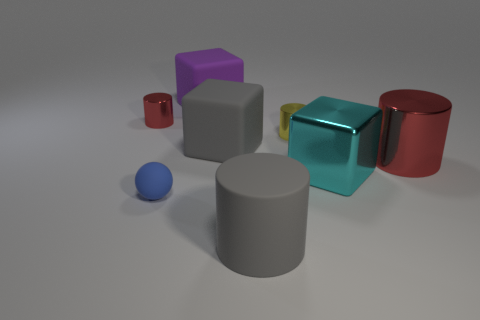Add 1 gray things. How many objects exist? 9 Subtract all purple cylinders. Subtract all red balls. How many cylinders are left? 4 Subtract all gray spheres. How many brown cylinders are left? 0 Subtract all large metal cubes. Subtract all large cyan shiny cubes. How many objects are left? 6 Add 6 large matte cubes. How many large matte cubes are left? 8 Add 8 tiny yellow matte cylinders. How many tiny yellow matte cylinders exist? 8 Subtract all gray cubes. How many cubes are left? 2 Subtract all large rubber blocks. How many blocks are left? 1 Subtract 1 yellow cylinders. How many objects are left? 7 Subtract all cubes. How many objects are left? 5 